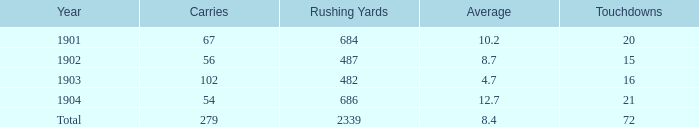What is the mean count of carries with over 72 touchdowns? None. 